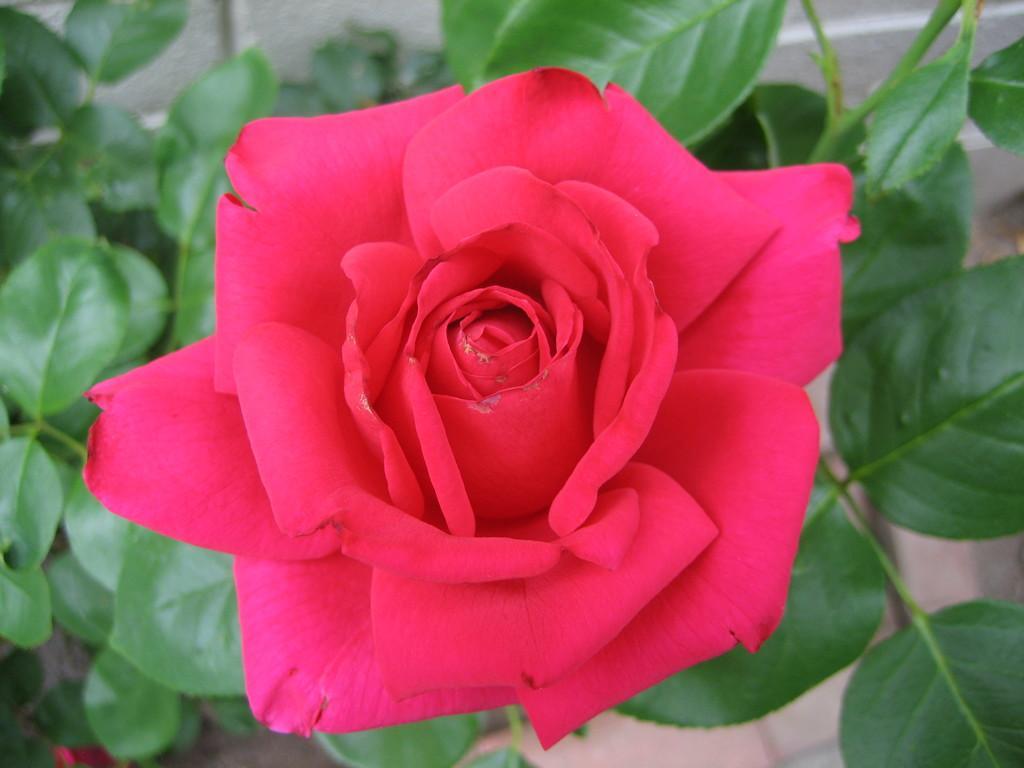How would you summarize this image in a sentence or two? This image consists of red rose along with green leaves. At the bottom, there is a floor. 